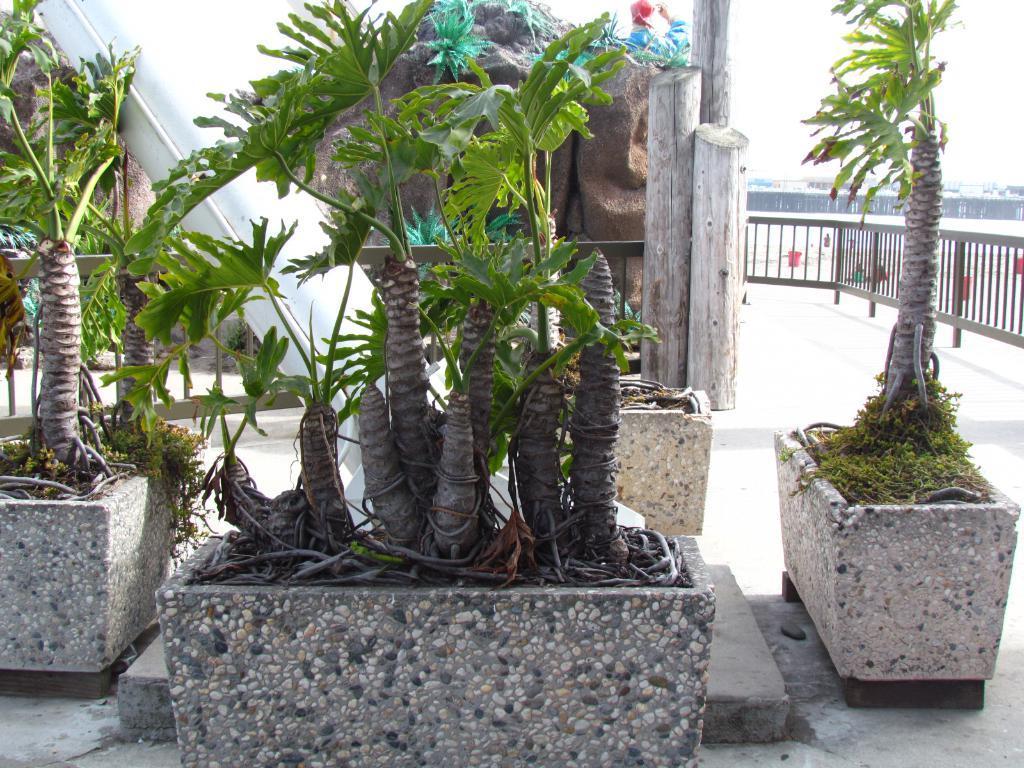Describe this image in one or two sentences. In the center of the image we can see the carving on the stone, plants, logs and a person is standing and holding an object. In the background of the image we can see the railing, pipe, pots, plants, floor, fence, buckets. In the top right corner we can see the sky. 